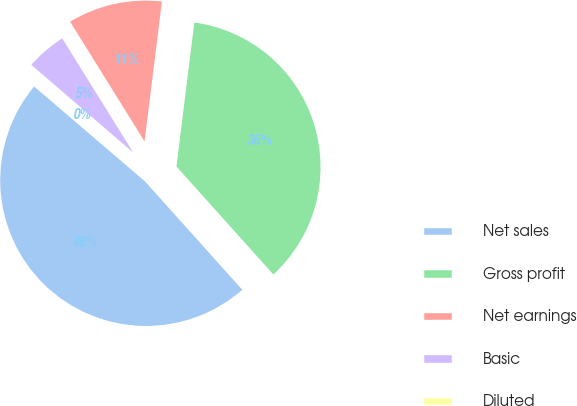Convert chart to OTSL. <chart><loc_0><loc_0><loc_500><loc_500><pie_chart><fcel>Net sales<fcel>Gross profit<fcel>Net earnings<fcel>Basic<fcel>Diluted<nl><fcel>47.91%<fcel>36.39%<fcel>10.82%<fcel>4.83%<fcel>0.05%<nl></chart> 